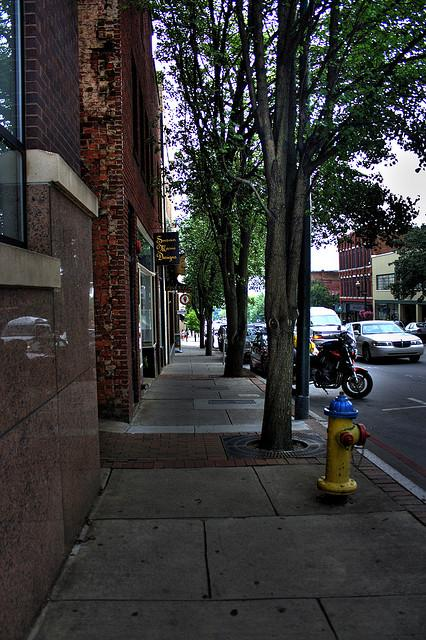What is the yellow object on the sidewalk connected to? pipes 